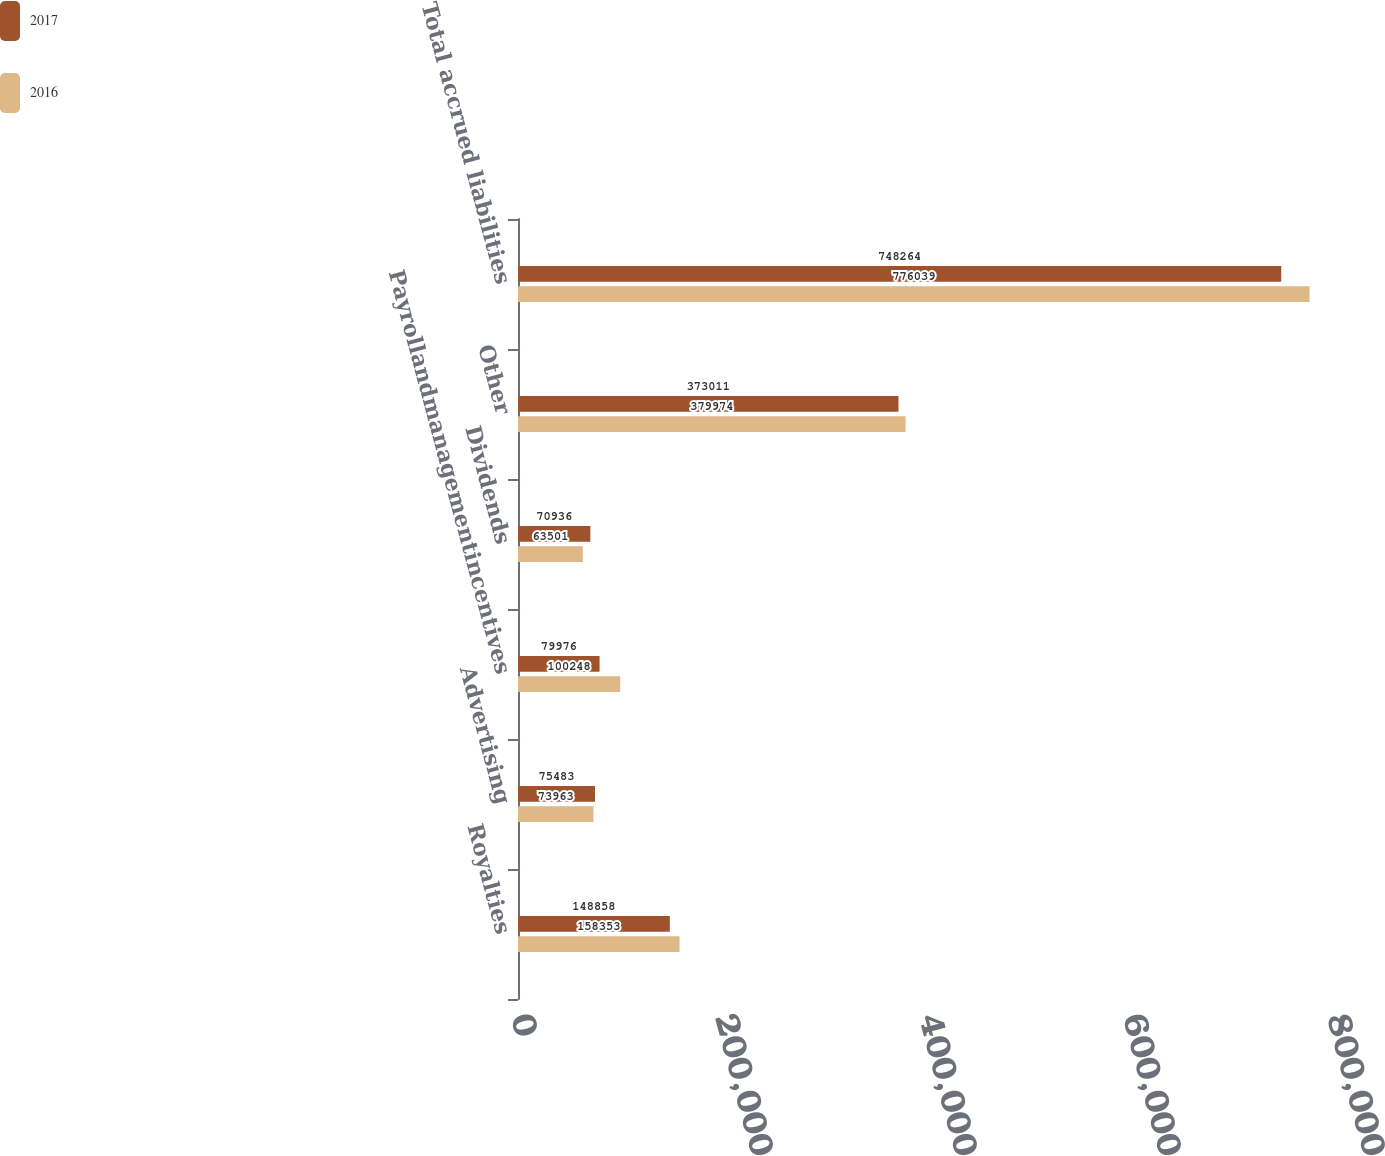Convert chart. <chart><loc_0><loc_0><loc_500><loc_500><stacked_bar_chart><ecel><fcel>Royalties<fcel>Advertising<fcel>Payrollandmanagementincentives<fcel>Dividends<fcel>Other<fcel>Total accrued liabilities<nl><fcel>2017<fcel>148858<fcel>75483<fcel>79976<fcel>70936<fcel>373011<fcel>748264<nl><fcel>2016<fcel>158353<fcel>73963<fcel>100248<fcel>63501<fcel>379974<fcel>776039<nl></chart> 